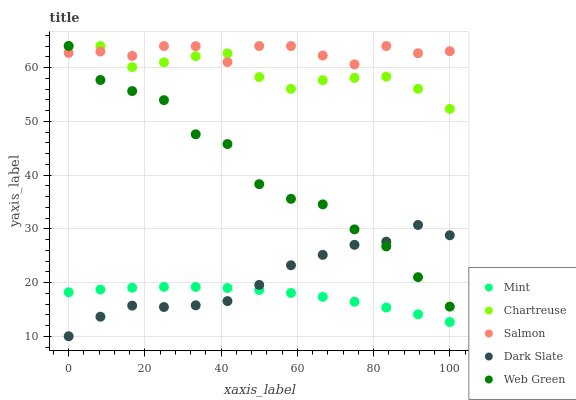Does Mint have the minimum area under the curve?
Answer yes or no. Yes. Does Salmon have the maximum area under the curve?
Answer yes or no. Yes. Does Chartreuse have the minimum area under the curve?
Answer yes or no. No. Does Chartreuse have the maximum area under the curve?
Answer yes or no. No. Is Mint the smoothest?
Answer yes or no. Yes. Is Web Green the roughest?
Answer yes or no. Yes. Is Chartreuse the smoothest?
Answer yes or no. No. Is Chartreuse the roughest?
Answer yes or no. No. Does Dark Slate have the lowest value?
Answer yes or no. Yes. Does Chartreuse have the lowest value?
Answer yes or no. No. Does Web Green have the highest value?
Answer yes or no. Yes. Does Mint have the highest value?
Answer yes or no. No. Is Dark Slate less than Chartreuse?
Answer yes or no. Yes. Is Web Green greater than Mint?
Answer yes or no. Yes. Does Web Green intersect Salmon?
Answer yes or no. Yes. Is Web Green less than Salmon?
Answer yes or no. No. Is Web Green greater than Salmon?
Answer yes or no. No. Does Dark Slate intersect Chartreuse?
Answer yes or no. No. 